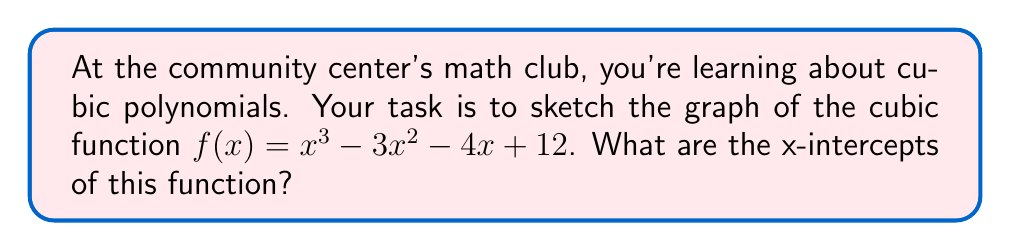Give your solution to this math problem. Let's approach this step-by-step:

1) To find the x-intercepts, we need to solve the equation $f(x) = 0$:

   $x^3 - 3x^2 - 4x + 12 = 0$

2) This is a cubic equation. One way to solve it is by factoring. Let's try to guess one factor:
   
   $x = 2$ makes $f(2) = 2^3 - 3(2^2) - 4(2) + 12 = 8 - 12 - 8 + 12 = 0$

3) So $(x - 2)$ is a factor. We can divide the original polynomial by $(x - 2)$:

   $\frac{x^3 - 3x^2 - 4x + 12}{x - 2} = x^2 - x - 6$

4) Now our equation becomes:

   $(x - 2)(x^2 - x - 6) = 0$

5) We can factor the quadratic term:

   $(x - 2)(x - 3)(x + 2) = 0$

6) By the zero product property, the solutions are:

   $x = 2$, $x = 3$, or $x = -2$

These are the x-intercepts of the function.

To sketch the graph:

- The function crosses the x-axis at $x = -2$, $x = 2$, and $x = 3$.
- As a cubic function, it will have one inflection point.
- The leading coefficient is positive, so as $x$ approaches infinity, $f(x)$ approaches positive infinity, and as $x$ approaches negative infinity, $f(x)$ approaches negative infinity.

[asy]
import graph;
size(200,200);
real f(real x) {return x^3 - 3x^2 - 4x + 12;}
draw(graph(f,-3,4),blue);
xaxis("x",-3,4,Arrow);
yaxis("y",-10,20,Arrow);
dot((-2,0));
dot((2,0));
dot((3,0));
label("(-2,0)",(-2,0),SW);
label("(2,0)",(2,0),SE);
label("(3,0)",(3,0),NE);
[/asy]
Answer: The x-intercepts of the function $f(x) = x^3 - 3x^2 - 4x + 12$ are $x = -2$, $x = 2$, and $x = 3$. 